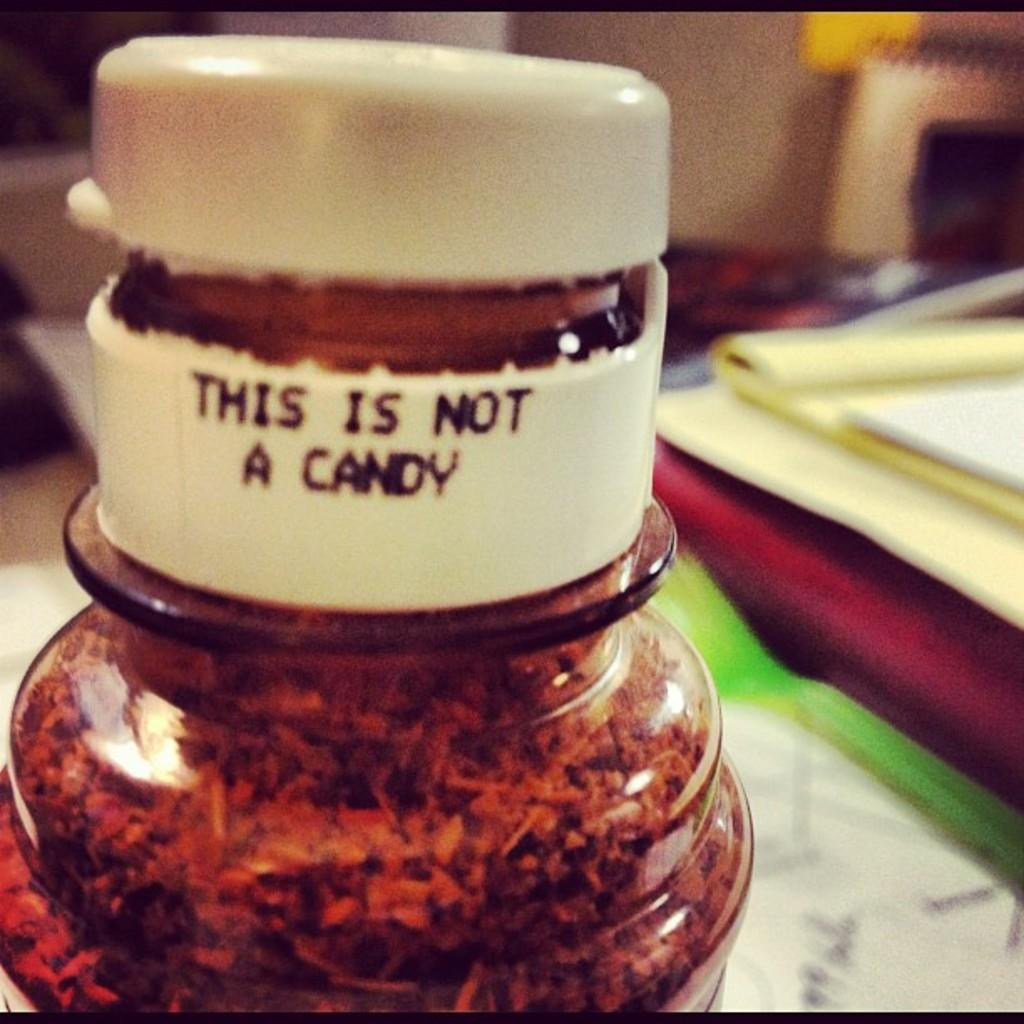What is the main object in the center of the image? There is a bottle in the center of the image. What other items can be seen on the right side of the image? Papers and books are on the right side of the image. What is visible in the background of the image? There is a wall and a book in the background of the image. How many lines can be seen on the building in the image? There is no building present in the image, so it is not possible to determine the number of lines on a building. 